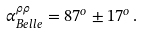Convert formula to latex. <formula><loc_0><loc_0><loc_500><loc_500>\alpha ^ { \rho \rho } _ { B e l l e } = 8 7 ^ { o } \pm 1 7 ^ { o } \, .</formula> 